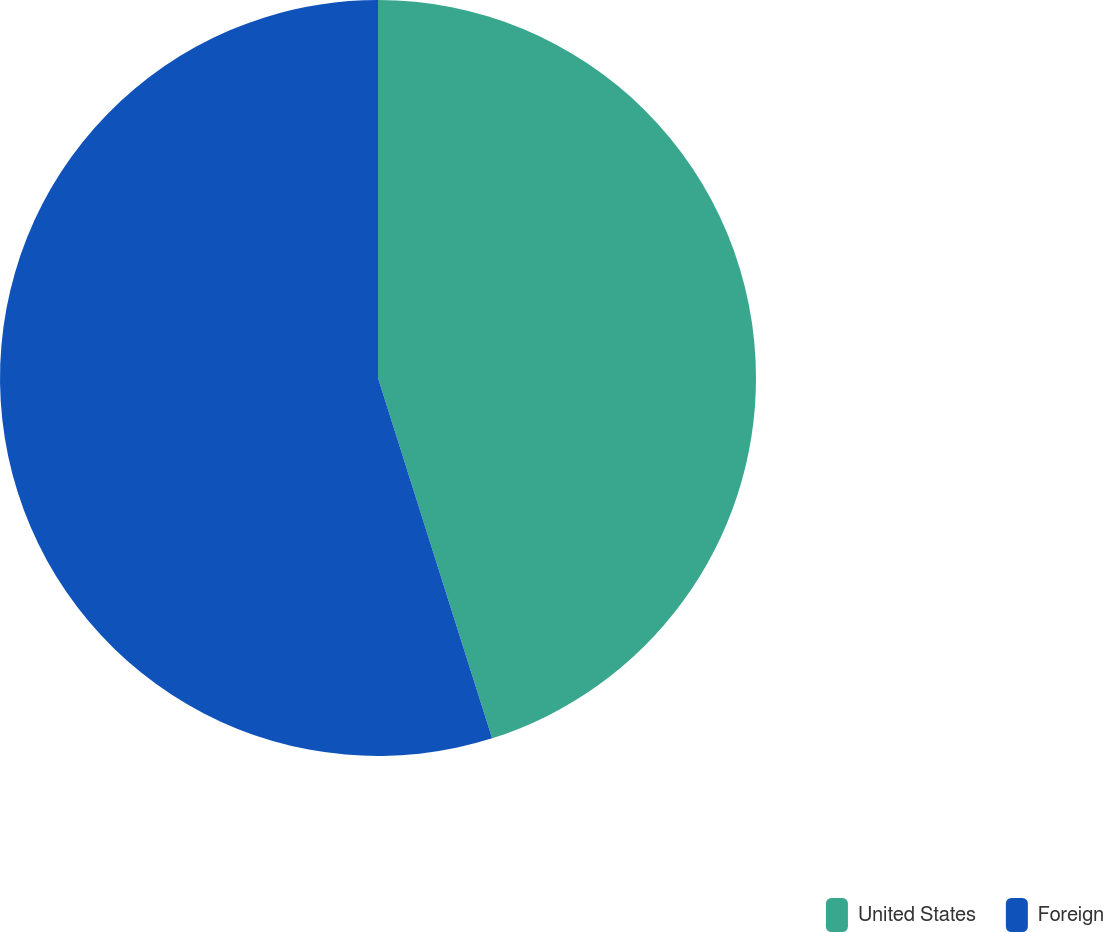Convert chart. <chart><loc_0><loc_0><loc_500><loc_500><pie_chart><fcel>United States<fcel>Foreign<nl><fcel>45.12%<fcel>54.88%<nl></chart> 